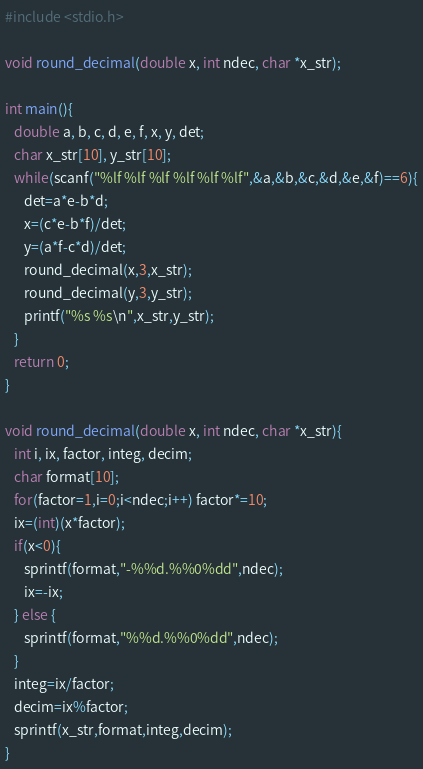<code> <loc_0><loc_0><loc_500><loc_500><_C_>#include <stdio.h>

void round_decimal(double x, int ndec, char *x_str);

int main(){
   double a, b, c, d, e, f, x, y, det;
   char x_str[10], y_str[10];
   while(scanf("%lf %lf %lf %lf %lf %lf",&a,&b,&c,&d,&e,&f)==6){
      det=a*e-b*d;
      x=(c*e-b*f)/det;
      y=(a*f-c*d)/det;
      round_decimal(x,3,x_str);
      round_decimal(y,3,y_str);
      printf("%s %s\n",x_str,y_str);
   }
   return 0;
}

void round_decimal(double x, int ndec, char *x_str){
   int i, ix, factor, integ, decim;
   char format[10];
   for(factor=1,i=0;i<ndec;i++) factor*=10;
   ix=(int)(x*factor);
   if(x<0){
      sprintf(format,"-%%d.%%0%dd",ndec);
      ix=-ix;
   } else {
      sprintf(format,"%%d.%%0%dd",ndec);
   }
   integ=ix/factor;
   decim=ix%factor;
   sprintf(x_str,format,integ,decim);
}</code> 